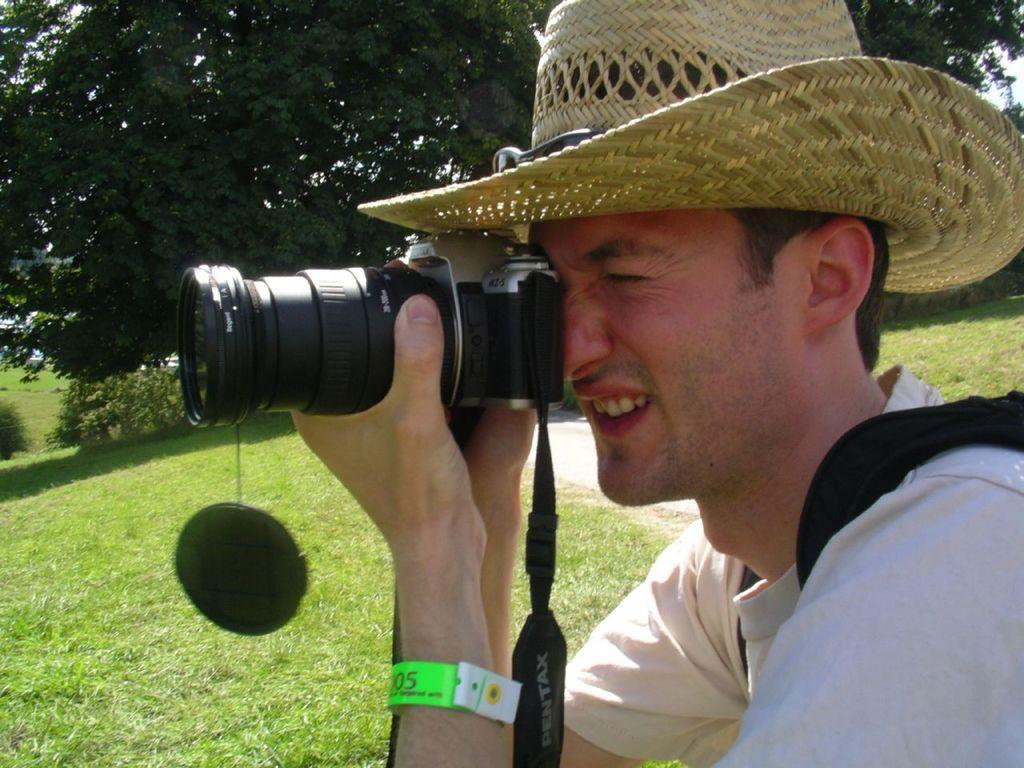How would you summarize this image in a sentence or two? In this picture there is man wearing a hat, clicking a picture with his camera. There is a grass on the land and some trees in the background. 